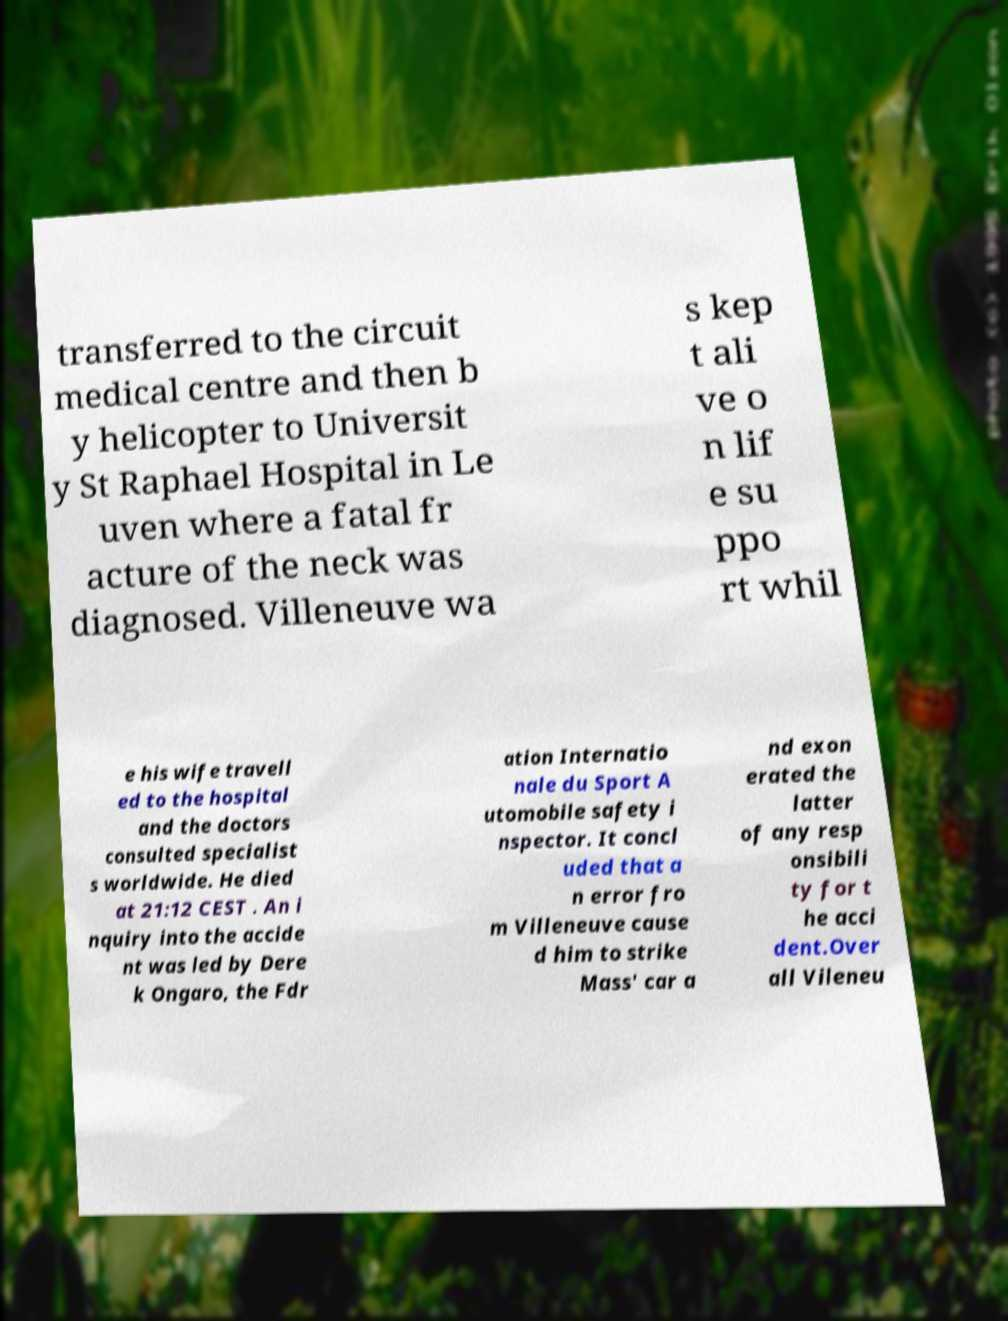Could you assist in decoding the text presented in this image and type it out clearly? transferred to the circuit medical centre and then b y helicopter to Universit y St Raphael Hospital in Le uven where a fatal fr acture of the neck was diagnosed. Villeneuve wa s kep t ali ve o n lif e su ppo rt whil e his wife travell ed to the hospital and the doctors consulted specialist s worldwide. He died at 21:12 CEST . An i nquiry into the accide nt was led by Dere k Ongaro, the Fdr ation Internatio nale du Sport A utomobile safety i nspector. It concl uded that a n error fro m Villeneuve cause d him to strike Mass' car a nd exon erated the latter of any resp onsibili ty for t he acci dent.Over all Vileneu 